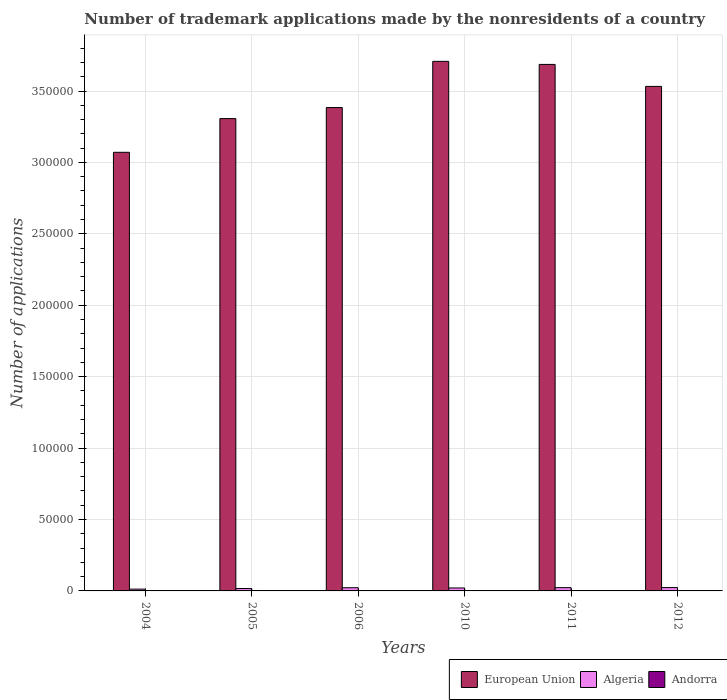How many different coloured bars are there?
Your answer should be compact. 3. How many groups of bars are there?
Ensure brevity in your answer.  6. Are the number of bars per tick equal to the number of legend labels?
Keep it short and to the point. Yes. How many bars are there on the 5th tick from the left?
Keep it short and to the point. 3. How many bars are there on the 2nd tick from the right?
Your answer should be very brief. 3. In how many cases, is the number of bars for a given year not equal to the number of legend labels?
Provide a succinct answer. 0. What is the number of trademark applications made by the nonresidents in European Union in 2006?
Offer a terse response. 3.38e+05. Across all years, what is the maximum number of trademark applications made by the nonresidents in European Union?
Keep it short and to the point. 3.71e+05. Across all years, what is the minimum number of trademark applications made by the nonresidents in Algeria?
Provide a short and direct response. 1266. What is the total number of trademark applications made by the nonresidents in Algeria in the graph?
Provide a succinct answer. 1.19e+04. What is the difference between the number of trademark applications made by the nonresidents in Algeria in 2004 and that in 2006?
Your answer should be very brief. -969. What is the difference between the number of trademark applications made by the nonresidents in European Union in 2005 and the number of trademark applications made by the nonresidents in Andorra in 2006?
Provide a succinct answer. 3.30e+05. What is the average number of trademark applications made by the nonresidents in European Union per year?
Ensure brevity in your answer.  3.45e+05. In the year 2010, what is the difference between the number of trademark applications made by the nonresidents in Algeria and number of trademark applications made by the nonresidents in Andorra?
Your response must be concise. 1811. What is the ratio of the number of trademark applications made by the nonresidents in Algeria in 2011 to that in 2012?
Give a very brief answer. 0.98. What is the difference between the highest and the second highest number of trademark applications made by the nonresidents in Algeria?
Give a very brief answer. 38. What is the difference between the highest and the lowest number of trademark applications made by the nonresidents in European Union?
Your answer should be very brief. 6.37e+04. In how many years, is the number of trademark applications made by the nonresidents in Andorra greater than the average number of trademark applications made by the nonresidents in Andorra taken over all years?
Make the answer very short. 3. What does the 1st bar from the left in 2011 represents?
Give a very brief answer. European Union. What does the 1st bar from the right in 2012 represents?
Offer a terse response. Andorra. How many bars are there?
Make the answer very short. 18. Are all the bars in the graph horizontal?
Provide a succinct answer. No. How many years are there in the graph?
Offer a terse response. 6. What is the difference between two consecutive major ticks on the Y-axis?
Give a very brief answer. 5.00e+04. Are the values on the major ticks of Y-axis written in scientific E-notation?
Ensure brevity in your answer.  No. Does the graph contain any zero values?
Give a very brief answer. No. Where does the legend appear in the graph?
Offer a terse response. Bottom right. How many legend labels are there?
Provide a succinct answer. 3. What is the title of the graph?
Your answer should be compact. Number of trademark applications made by the nonresidents of a country. What is the label or title of the X-axis?
Make the answer very short. Years. What is the label or title of the Y-axis?
Offer a very short reply. Number of applications. What is the Number of applications in European Union in 2004?
Provide a succinct answer. 3.07e+05. What is the Number of applications of Algeria in 2004?
Your answer should be compact. 1266. What is the Number of applications of Andorra in 2004?
Your answer should be compact. 202. What is the Number of applications in European Union in 2005?
Your answer should be compact. 3.31e+05. What is the Number of applications of Algeria in 2005?
Ensure brevity in your answer.  1676. What is the Number of applications in Andorra in 2005?
Your response must be concise. 304. What is the Number of applications in European Union in 2006?
Ensure brevity in your answer.  3.38e+05. What is the Number of applications in Algeria in 2006?
Offer a very short reply. 2235. What is the Number of applications in Andorra in 2006?
Keep it short and to the point. 239. What is the Number of applications of European Union in 2010?
Keep it short and to the point. 3.71e+05. What is the Number of applications of Algeria in 2010?
Provide a succinct answer. 2070. What is the Number of applications in Andorra in 2010?
Provide a short and direct response. 259. What is the Number of applications of European Union in 2011?
Your answer should be very brief. 3.69e+05. What is the Number of applications of Algeria in 2011?
Provide a succinct answer. 2294. What is the Number of applications in Andorra in 2011?
Your answer should be very brief. 225. What is the Number of applications in European Union in 2012?
Provide a succinct answer. 3.53e+05. What is the Number of applications in Algeria in 2012?
Keep it short and to the point. 2332. What is the Number of applications of Andorra in 2012?
Ensure brevity in your answer.  182. Across all years, what is the maximum Number of applications in European Union?
Keep it short and to the point. 3.71e+05. Across all years, what is the maximum Number of applications in Algeria?
Your answer should be compact. 2332. Across all years, what is the maximum Number of applications in Andorra?
Give a very brief answer. 304. Across all years, what is the minimum Number of applications in European Union?
Offer a terse response. 3.07e+05. Across all years, what is the minimum Number of applications in Algeria?
Your answer should be very brief. 1266. Across all years, what is the minimum Number of applications in Andorra?
Offer a very short reply. 182. What is the total Number of applications in European Union in the graph?
Ensure brevity in your answer.  2.07e+06. What is the total Number of applications of Algeria in the graph?
Offer a terse response. 1.19e+04. What is the total Number of applications in Andorra in the graph?
Ensure brevity in your answer.  1411. What is the difference between the Number of applications in European Union in 2004 and that in 2005?
Ensure brevity in your answer.  -2.36e+04. What is the difference between the Number of applications of Algeria in 2004 and that in 2005?
Your response must be concise. -410. What is the difference between the Number of applications of Andorra in 2004 and that in 2005?
Offer a terse response. -102. What is the difference between the Number of applications of European Union in 2004 and that in 2006?
Your answer should be very brief. -3.13e+04. What is the difference between the Number of applications of Algeria in 2004 and that in 2006?
Provide a succinct answer. -969. What is the difference between the Number of applications of Andorra in 2004 and that in 2006?
Give a very brief answer. -37. What is the difference between the Number of applications of European Union in 2004 and that in 2010?
Your answer should be very brief. -6.37e+04. What is the difference between the Number of applications of Algeria in 2004 and that in 2010?
Ensure brevity in your answer.  -804. What is the difference between the Number of applications of Andorra in 2004 and that in 2010?
Offer a terse response. -57. What is the difference between the Number of applications in European Union in 2004 and that in 2011?
Provide a succinct answer. -6.15e+04. What is the difference between the Number of applications in Algeria in 2004 and that in 2011?
Provide a short and direct response. -1028. What is the difference between the Number of applications of European Union in 2004 and that in 2012?
Your answer should be very brief. -4.61e+04. What is the difference between the Number of applications of Algeria in 2004 and that in 2012?
Provide a succinct answer. -1066. What is the difference between the Number of applications of Andorra in 2004 and that in 2012?
Ensure brevity in your answer.  20. What is the difference between the Number of applications of European Union in 2005 and that in 2006?
Your answer should be very brief. -7738. What is the difference between the Number of applications of Algeria in 2005 and that in 2006?
Provide a succinct answer. -559. What is the difference between the Number of applications in European Union in 2005 and that in 2010?
Your answer should be very brief. -4.01e+04. What is the difference between the Number of applications in Algeria in 2005 and that in 2010?
Offer a very short reply. -394. What is the difference between the Number of applications of Andorra in 2005 and that in 2010?
Your answer should be compact. 45. What is the difference between the Number of applications in European Union in 2005 and that in 2011?
Provide a short and direct response. -3.79e+04. What is the difference between the Number of applications of Algeria in 2005 and that in 2011?
Ensure brevity in your answer.  -618. What is the difference between the Number of applications in Andorra in 2005 and that in 2011?
Your answer should be compact. 79. What is the difference between the Number of applications of European Union in 2005 and that in 2012?
Offer a very short reply. -2.25e+04. What is the difference between the Number of applications in Algeria in 2005 and that in 2012?
Your response must be concise. -656. What is the difference between the Number of applications in Andorra in 2005 and that in 2012?
Ensure brevity in your answer.  122. What is the difference between the Number of applications of European Union in 2006 and that in 2010?
Give a very brief answer. -3.23e+04. What is the difference between the Number of applications in Algeria in 2006 and that in 2010?
Give a very brief answer. 165. What is the difference between the Number of applications of European Union in 2006 and that in 2011?
Your answer should be compact. -3.02e+04. What is the difference between the Number of applications of Algeria in 2006 and that in 2011?
Give a very brief answer. -59. What is the difference between the Number of applications in Andorra in 2006 and that in 2011?
Your answer should be very brief. 14. What is the difference between the Number of applications in European Union in 2006 and that in 2012?
Offer a very short reply. -1.48e+04. What is the difference between the Number of applications of Algeria in 2006 and that in 2012?
Your answer should be very brief. -97. What is the difference between the Number of applications of European Union in 2010 and that in 2011?
Ensure brevity in your answer.  2138. What is the difference between the Number of applications in Algeria in 2010 and that in 2011?
Keep it short and to the point. -224. What is the difference between the Number of applications of Andorra in 2010 and that in 2011?
Your response must be concise. 34. What is the difference between the Number of applications in European Union in 2010 and that in 2012?
Offer a terse response. 1.75e+04. What is the difference between the Number of applications of Algeria in 2010 and that in 2012?
Give a very brief answer. -262. What is the difference between the Number of applications in Andorra in 2010 and that in 2012?
Your answer should be very brief. 77. What is the difference between the Number of applications in European Union in 2011 and that in 2012?
Offer a very short reply. 1.54e+04. What is the difference between the Number of applications of Algeria in 2011 and that in 2012?
Ensure brevity in your answer.  -38. What is the difference between the Number of applications in Andorra in 2011 and that in 2012?
Offer a very short reply. 43. What is the difference between the Number of applications in European Union in 2004 and the Number of applications in Algeria in 2005?
Offer a very short reply. 3.05e+05. What is the difference between the Number of applications of European Union in 2004 and the Number of applications of Andorra in 2005?
Make the answer very short. 3.07e+05. What is the difference between the Number of applications of Algeria in 2004 and the Number of applications of Andorra in 2005?
Ensure brevity in your answer.  962. What is the difference between the Number of applications in European Union in 2004 and the Number of applications in Algeria in 2006?
Give a very brief answer. 3.05e+05. What is the difference between the Number of applications in European Union in 2004 and the Number of applications in Andorra in 2006?
Provide a succinct answer. 3.07e+05. What is the difference between the Number of applications in Algeria in 2004 and the Number of applications in Andorra in 2006?
Give a very brief answer. 1027. What is the difference between the Number of applications of European Union in 2004 and the Number of applications of Algeria in 2010?
Ensure brevity in your answer.  3.05e+05. What is the difference between the Number of applications of European Union in 2004 and the Number of applications of Andorra in 2010?
Provide a succinct answer. 3.07e+05. What is the difference between the Number of applications of Algeria in 2004 and the Number of applications of Andorra in 2010?
Make the answer very short. 1007. What is the difference between the Number of applications in European Union in 2004 and the Number of applications in Algeria in 2011?
Your answer should be very brief. 3.05e+05. What is the difference between the Number of applications of European Union in 2004 and the Number of applications of Andorra in 2011?
Your answer should be compact. 3.07e+05. What is the difference between the Number of applications in Algeria in 2004 and the Number of applications in Andorra in 2011?
Keep it short and to the point. 1041. What is the difference between the Number of applications in European Union in 2004 and the Number of applications in Algeria in 2012?
Offer a very short reply. 3.05e+05. What is the difference between the Number of applications in European Union in 2004 and the Number of applications in Andorra in 2012?
Offer a very short reply. 3.07e+05. What is the difference between the Number of applications in Algeria in 2004 and the Number of applications in Andorra in 2012?
Your answer should be compact. 1084. What is the difference between the Number of applications of European Union in 2005 and the Number of applications of Algeria in 2006?
Keep it short and to the point. 3.28e+05. What is the difference between the Number of applications of European Union in 2005 and the Number of applications of Andorra in 2006?
Your answer should be very brief. 3.30e+05. What is the difference between the Number of applications of Algeria in 2005 and the Number of applications of Andorra in 2006?
Offer a very short reply. 1437. What is the difference between the Number of applications in European Union in 2005 and the Number of applications in Algeria in 2010?
Keep it short and to the point. 3.29e+05. What is the difference between the Number of applications of European Union in 2005 and the Number of applications of Andorra in 2010?
Make the answer very short. 3.30e+05. What is the difference between the Number of applications in Algeria in 2005 and the Number of applications in Andorra in 2010?
Your response must be concise. 1417. What is the difference between the Number of applications in European Union in 2005 and the Number of applications in Algeria in 2011?
Give a very brief answer. 3.28e+05. What is the difference between the Number of applications in European Union in 2005 and the Number of applications in Andorra in 2011?
Offer a terse response. 3.30e+05. What is the difference between the Number of applications in Algeria in 2005 and the Number of applications in Andorra in 2011?
Your answer should be very brief. 1451. What is the difference between the Number of applications of European Union in 2005 and the Number of applications of Algeria in 2012?
Provide a succinct answer. 3.28e+05. What is the difference between the Number of applications in European Union in 2005 and the Number of applications in Andorra in 2012?
Offer a very short reply. 3.31e+05. What is the difference between the Number of applications of Algeria in 2005 and the Number of applications of Andorra in 2012?
Provide a succinct answer. 1494. What is the difference between the Number of applications of European Union in 2006 and the Number of applications of Algeria in 2010?
Your answer should be very brief. 3.36e+05. What is the difference between the Number of applications of European Union in 2006 and the Number of applications of Andorra in 2010?
Make the answer very short. 3.38e+05. What is the difference between the Number of applications of Algeria in 2006 and the Number of applications of Andorra in 2010?
Keep it short and to the point. 1976. What is the difference between the Number of applications in European Union in 2006 and the Number of applications in Algeria in 2011?
Give a very brief answer. 3.36e+05. What is the difference between the Number of applications in European Union in 2006 and the Number of applications in Andorra in 2011?
Offer a very short reply. 3.38e+05. What is the difference between the Number of applications in Algeria in 2006 and the Number of applications in Andorra in 2011?
Offer a terse response. 2010. What is the difference between the Number of applications in European Union in 2006 and the Number of applications in Algeria in 2012?
Keep it short and to the point. 3.36e+05. What is the difference between the Number of applications of European Union in 2006 and the Number of applications of Andorra in 2012?
Your response must be concise. 3.38e+05. What is the difference between the Number of applications in Algeria in 2006 and the Number of applications in Andorra in 2012?
Give a very brief answer. 2053. What is the difference between the Number of applications in European Union in 2010 and the Number of applications in Algeria in 2011?
Offer a very short reply. 3.68e+05. What is the difference between the Number of applications of European Union in 2010 and the Number of applications of Andorra in 2011?
Provide a succinct answer. 3.71e+05. What is the difference between the Number of applications of Algeria in 2010 and the Number of applications of Andorra in 2011?
Your response must be concise. 1845. What is the difference between the Number of applications in European Union in 2010 and the Number of applications in Algeria in 2012?
Offer a very short reply. 3.68e+05. What is the difference between the Number of applications in European Union in 2010 and the Number of applications in Andorra in 2012?
Provide a short and direct response. 3.71e+05. What is the difference between the Number of applications of Algeria in 2010 and the Number of applications of Andorra in 2012?
Provide a succinct answer. 1888. What is the difference between the Number of applications in European Union in 2011 and the Number of applications in Algeria in 2012?
Your response must be concise. 3.66e+05. What is the difference between the Number of applications of European Union in 2011 and the Number of applications of Andorra in 2012?
Provide a short and direct response. 3.68e+05. What is the difference between the Number of applications of Algeria in 2011 and the Number of applications of Andorra in 2012?
Your answer should be very brief. 2112. What is the average Number of applications in European Union per year?
Offer a terse response. 3.45e+05. What is the average Number of applications of Algeria per year?
Give a very brief answer. 1978.83. What is the average Number of applications in Andorra per year?
Provide a short and direct response. 235.17. In the year 2004, what is the difference between the Number of applications in European Union and Number of applications in Algeria?
Offer a terse response. 3.06e+05. In the year 2004, what is the difference between the Number of applications in European Union and Number of applications in Andorra?
Ensure brevity in your answer.  3.07e+05. In the year 2004, what is the difference between the Number of applications of Algeria and Number of applications of Andorra?
Your answer should be compact. 1064. In the year 2005, what is the difference between the Number of applications of European Union and Number of applications of Algeria?
Offer a terse response. 3.29e+05. In the year 2005, what is the difference between the Number of applications in European Union and Number of applications in Andorra?
Provide a succinct answer. 3.30e+05. In the year 2005, what is the difference between the Number of applications in Algeria and Number of applications in Andorra?
Provide a short and direct response. 1372. In the year 2006, what is the difference between the Number of applications in European Union and Number of applications in Algeria?
Give a very brief answer. 3.36e+05. In the year 2006, what is the difference between the Number of applications of European Union and Number of applications of Andorra?
Give a very brief answer. 3.38e+05. In the year 2006, what is the difference between the Number of applications in Algeria and Number of applications in Andorra?
Offer a very short reply. 1996. In the year 2010, what is the difference between the Number of applications in European Union and Number of applications in Algeria?
Your answer should be compact. 3.69e+05. In the year 2010, what is the difference between the Number of applications in European Union and Number of applications in Andorra?
Your answer should be compact. 3.71e+05. In the year 2010, what is the difference between the Number of applications in Algeria and Number of applications in Andorra?
Provide a short and direct response. 1811. In the year 2011, what is the difference between the Number of applications in European Union and Number of applications in Algeria?
Make the answer very short. 3.66e+05. In the year 2011, what is the difference between the Number of applications of European Union and Number of applications of Andorra?
Give a very brief answer. 3.68e+05. In the year 2011, what is the difference between the Number of applications of Algeria and Number of applications of Andorra?
Offer a very short reply. 2069. In the year 2012, what is the difference between the Number of applications of European Union and Number of applications of Algeria?
Your answer should be compact. 3.51e+05. In the year 2012, what is the difference between the Number of applications in European Union and Number of applications in Andorra?
Ensure brevity in your answer.  3.53e+05. In the year 2012, what is the difference between the Number of applications of Algeria and Number of applications of Andorra?
Offer a terse response. 2150. What is the ratio of the Number of applications of European Union in 2004 to that in 2005?
Your answer should be compact. 0.93. What is the ratio of the Number of applications of Algeria in 2004 to that in 2005?
Offer a terse response. 0.76. What is the ratio of the Number of applications of Andorra in 2004 to that in 2005?
Ensure brevity in your answer.  0.66. What is the ratio of the Number of applications of European Union in 2004 to that in 2006?
Offer a very short reply. 0.91. What is the ratio of the Number of applications in Algeria in 2004 to that in 2006?
Your answer should be compact. 0.57. What is the ratio of the Number of applications of Andorra in 2004 to that in 2006?
Provide a short and direct response. 0.85. What is the ratio of the Number of applications in European Union in 2004 to that in 2010?
Your answer should be compact. 0.83. What is the ratio of the Number of applications in Algeria in 2004 to that in 2010?
Provide a succinct answer. 0.61. What is the ratio of the Number of applications in Andorra in 2004 to that in 2010?
Provide a succinct answer. 0.78. What is the ratio of the Number of applications of European Union in 2004 to that in 2011?
Keep it short and to the point. 0.83. What is the ratio of the Number of applications in Algeria in 2004 to that in 2011?
Ensure brevity in your answer.  0.55. What is the ratio of the Number of applications of Andorra in 2004 to that in 2011?
Give a very brief answer. 0.9. What is the ratio of the Number of applications of European Union in 2004 to that in 2012?
Your response must be concise. 0.87. What is the ratio of the Number of applications in Algeria in 2004 to that in 2012?
Ensure brevity in your answer.  0.54. What is the ratio of the Number of applications of Andorra in 2004 to that in 2012?
Offer a terse response. 1.11. What is the ratio of the Number of applications of European Union in 2005 to that in 2006?
Provide a short and direct response. 0.98. What is the ratio of the Number of applications of Algeria in 2005 to that in 2006?
Your answer should be very brief. 0.75. What is the ratio of the Number of applications of Andorra in 2005 to that in 2006?
Provide a succinct answer. 1.27. What is the ratio of the Number of applications in European Union in 2005 to that in 2010?
Give a very brief answer. 0.89. What is the ratio of the Number of applications of Algeria in 2005 to that in 2010?
Offer a terse response. 0.81. What is the ratio of the Number of applications of Andorra in 2005 to that in 2010?
Keep it short and to the point. 1.17. What is the ratio of the Number of applications in European Union in 2005 to that in 2011?
Ensure brevity in your answer.  0.9. What is the ratio of the Number of applications of Algeria in 2005 to that in 2011?
Provide a short and direct response. 0.73. What is the ratio of the Number of applications in Andorra in 2005 to that in 2011?
Your response must be concise. 1.35. What is the ratio of the Number of applications of European Union in 2005 to that in 2012?
Give a very brief answer. 0.94. What is the ratio of the Number of applications in Algeria in 2005 to that in 2012?
Your answer should be very brief. 0.72. What is the ratio of the Number of applications of Andorra in 2005 to that in 2012?
Give a very brief answer. 1.67. What is the ratio of the Number of applications of European Union in 2006 to that in 2010?
Make the answer very short. 0.91. What is the ratio of the Number of applications in Algeria in 2006 to that in 2010?
Offer a terse response. 1.08. What is the ratio of the Number of applications in Andorra in 2006 to that in 2010?
Ensure brevity in your answer.  0.92. What is the ratio of the Number of applications of European Union in 2006 to that in 2011?
Your response must be concise. 0.92. What is the ratio of the Number of applications of Algeria in 2006 to that in 2011?
Your response must be concise. 0.97. What is the ratio of the Number of applications of Andorra in 2006 to that in 2011?
Provide a short and direct response. 1.06. What is the ratio of the Number of applications in European Union in 2006 to that in 2012?
Your response must be concise. 0.96. What is the ratio of the Number of applications in Algeria in 2006 to that in 2012?
Offer a very short reply. 0.96. What is the ratio of the Number of applications in Andorra in 2006 to that in 2012?
Offer a terse response. 1.31. What is the ratio of the Number of applications in European Union in 2010 to that in 2011?
Keep it short and to the point. 1.01. What is the ratio of the Number of applications of Algeria in 2010 to that in 2011?
Keep it short and to the point. 0.9. What is the ratio of the Number of applications in Andorra in 2010 to that in 2011?
Your answer should be compact. 1.15. What is the ratio of the Number of applications in European Union in 2010 to that in 2012?
Your answer should be compact. 1.05. What is the ratio of the Number of applications of Algeria in 2010 to that in 2012?
Provide a short and direct response. 0.89. What is the ratio of the Number of applications in Andorra in 2010 to that in 2012?
Ensure brevity in your answer.  1.42. What is the ratio of the Number of applications in European Union in 2011 to that in 2012?
Keep it short and to the point. 1.04. What is the ratio of the Number of applications in Algeria in 2011 to that in 2012?
Provide a succinct answer. 0.98. What is the ratio of the Number of applications of Andorra in 2011 to that in 2012?
Provide a short and direct response. 1.24. What is the difference between the highest and the second highest Number of applications of European Union?
Your response must be concise. 2138. What is the difference between the highest and the second highest Number of applications in Andorra?
Your answer should be very brief. 45. What is the difference between the highest and the lowest Number of applications of European Union?
Offer a very short reply. 6.37e+04. What is the difference between the highest and the lowest Number of applications in Algeria?
Keep it short and to the point. 1066. What is the difference between the highest and the lowest Number of applications in Andorra?
Your answer should be very brief. 122. 